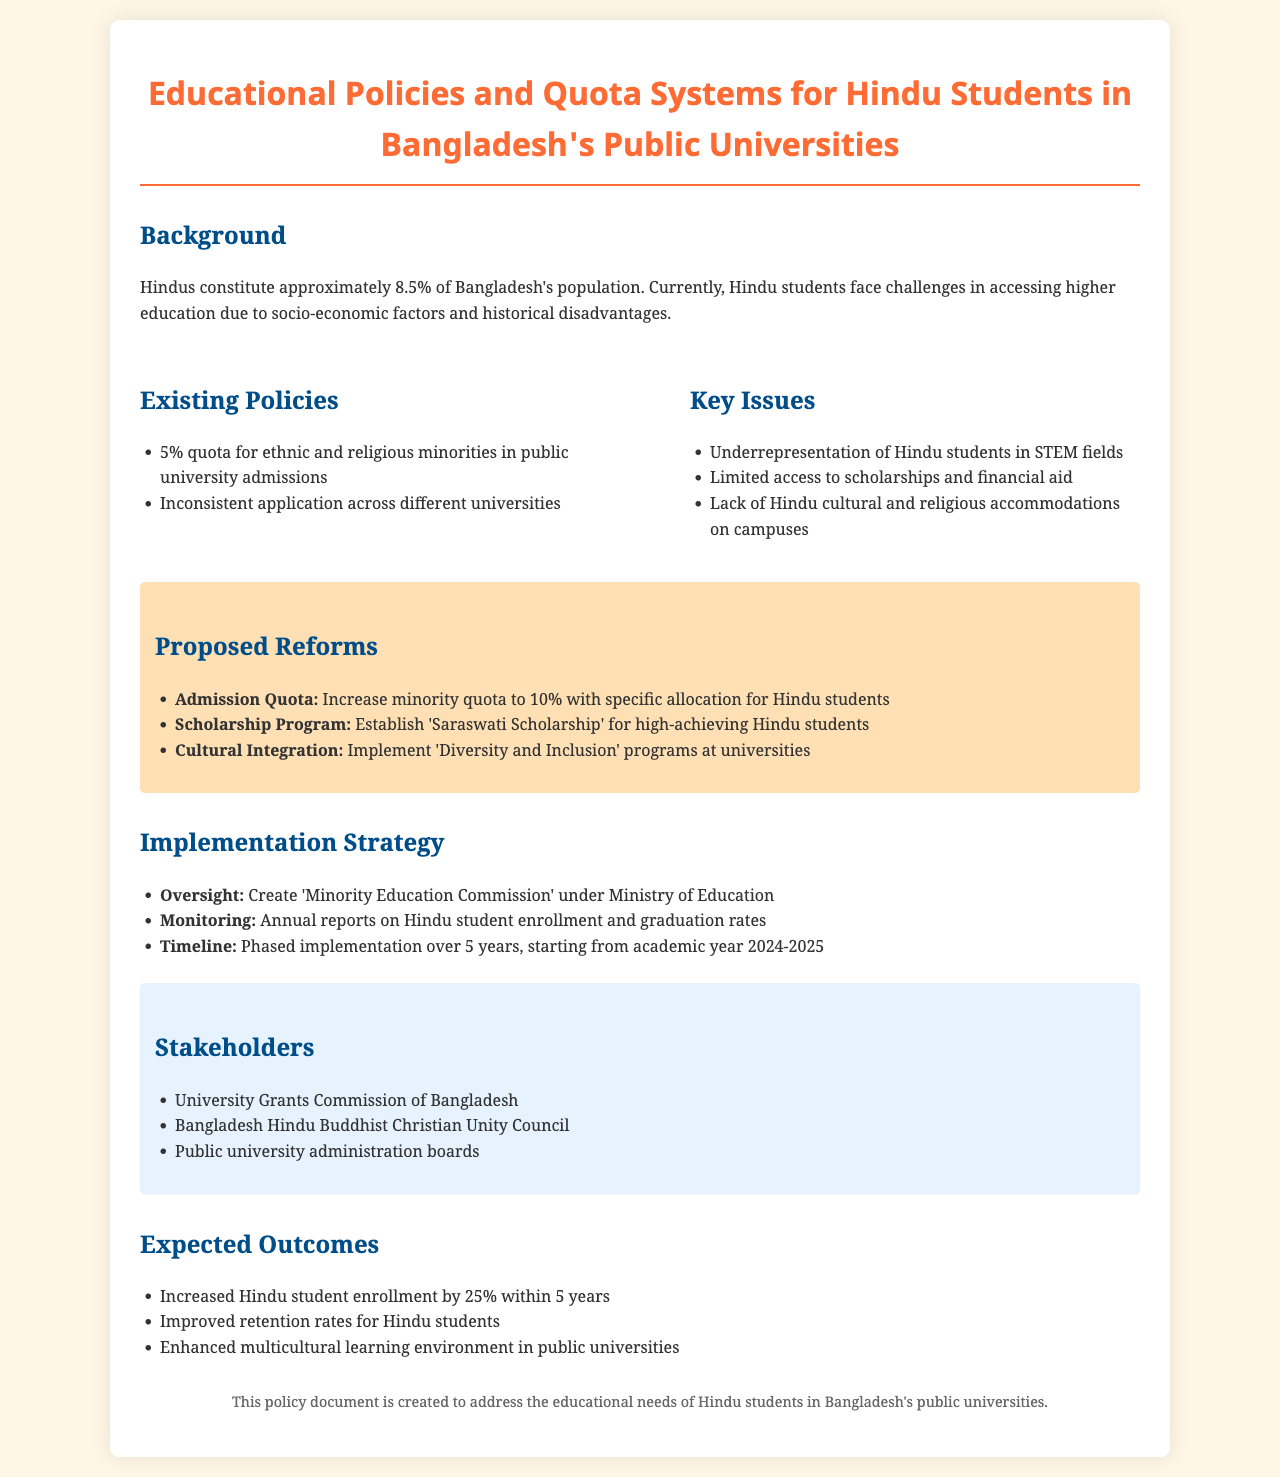What percentage of Bangladesh's population is Hindu? The document states that Hindus constitute approximately 8.5% of Bangladesh's population.
Answer: 8.5% What is the current quota percentage for ethnic and religious minorities in public universities? The document mentions a 5% quota for ethnic and religious minorities in public university admissions.
Answer: 5% What is one key issue faced by Hindu students in accessing higher education? The document highlights the underrepresentation of Hindu students in STEM fields as one key issue.
Answer: Underrepresentation in STEM fields What is the proposed increase for the minority quota? The document proposes to increase the minority quota to 10%.
Answer: 10% What is the name of the scholarship program established for high-achieving Hindu students? The document refers to the scholarship program as the 'Saraswati Scholarship'.
Answer: Saraswati Scholarship Who is responsible for monitoring Hindu student enrollment and graduation rates? The document indicates that the 'Minority Education Commission' will take responsibility for monitoring.
Answer: Minority Education Commission What is the expected increase in Hindu student enrollment within 5 years? The document states an expected increase of 25% in Hindu student enrollment within this timeframe.
Answer: 25% Which organization is one of the stakeholders mentioned in the document? The document lists the Bangladesh Hindu Buddhist Christian Unity Council as a stakeholder.
Answer: Bangladesh Hindu Buddhist Christian Unity Council What is the timeline for the phased implementation of the proposed reforms? The document specifies a timeline of phased implementation over 5 years, starting from academic year 2024-2025.
Answer: 5 years starting 2024-2025 